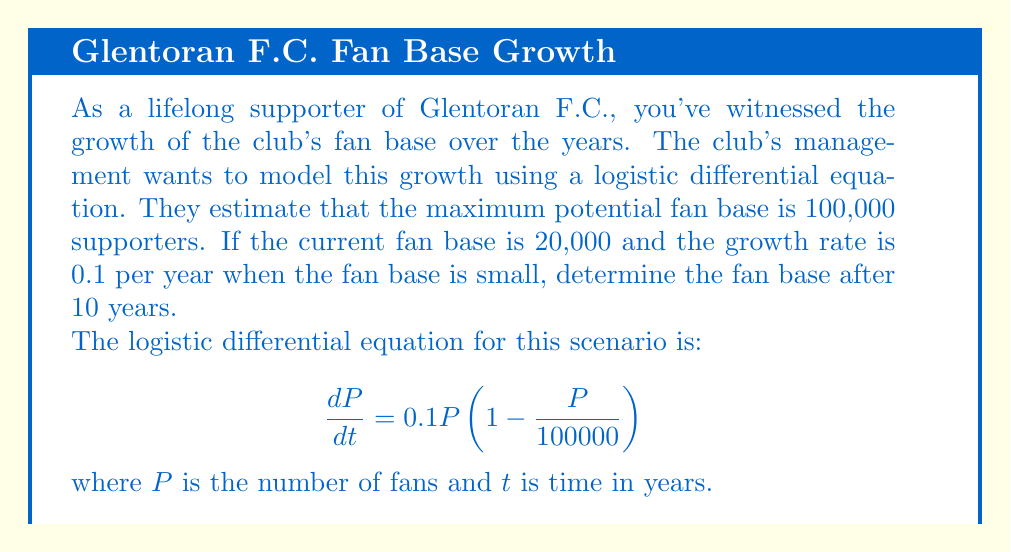Could you help me with this problem? Let's solve this step-by-step:

1) The general solution to the logistic differential equation is:

   $$P(t) = \frac{K}{1 + Ae^{-rt}}$$

   where $K$ is the carrying capacity (maximum fan base), $r$ is the growth rate, and $A$ is a constant to be determined.

2) We know:
   $K = 100000$
   $r = 0.1$
   $P(0) = 20000$ (initial fan base)

3) To find $A$, we use the initial condition:

   $$20000 = \frac{100000}{1 + A}$$

   $$A = 4$$

4) So our specific solution is:

   $$P(t) = \frac{100000}{1 + 4e^{-0.1t}}$$

5) To find the fan base after 10 years, we calculate $P(10)$:

   $$P(10) = \frac{100000}{1 + 4e^{-0.1(10)}}$$

6) Simplify:
   $$P(10) = \frac{100000}{1 + 4e^{-1}}$$
   $$P(10) = \frac{100000}{1 + 4(0.3679)}$$
   $$P(10) = \frac{100000}{2.4716}$$
   $$P(10) \approx 40460$$

Therefore, after 10 years, the fan base will be approximately 40,460 supporters.
Answer: 40,460 fans 